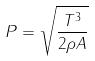<formula> <loc_0><loc_0><loc_500><loc_500>P = \sqrt { \frac { T ^ { 3 } } { 2 \rho A } }</formula> 